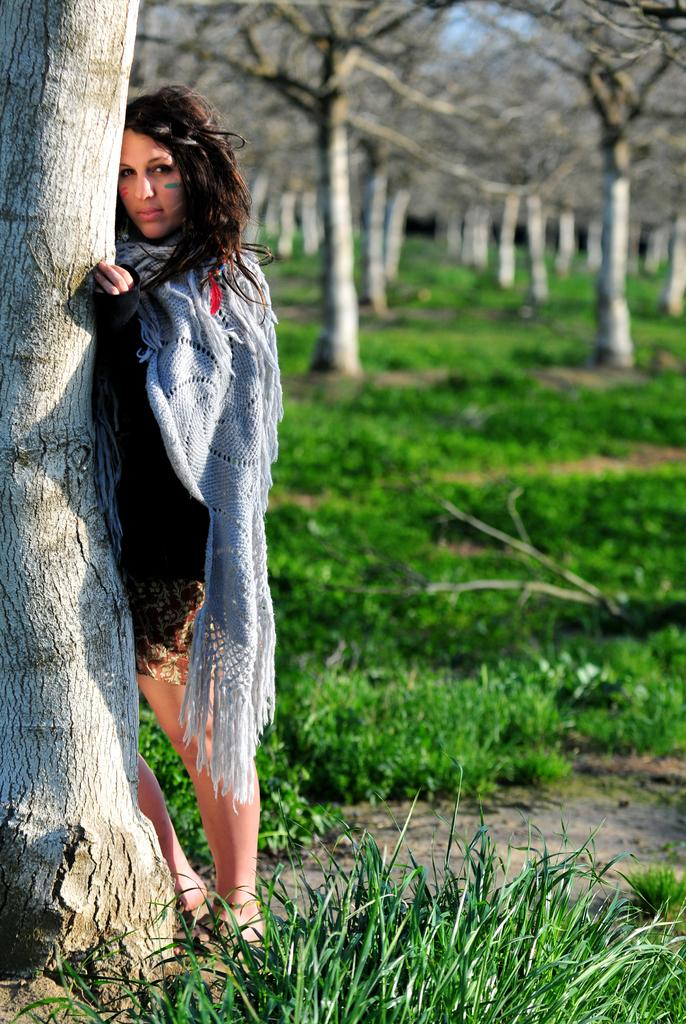What is the main subject of the image? There is a person standing in the image. Can you describe the person's attire? The person is wearing a black and gray color dress. What can be seen in the background of the image? Dried trees are visible in the background of the image. What is the color of the grass in the image? The grass is green in color. What is the color of the sky in the image? The sky is blue in color. Can you tell me how many pigs are present in the image? There are no pigs present in the image; it features a person standing in a landscape with dried trees, green grass, and a blue sky. What type of camp can be seen in the image? There is no camp present in the image. 